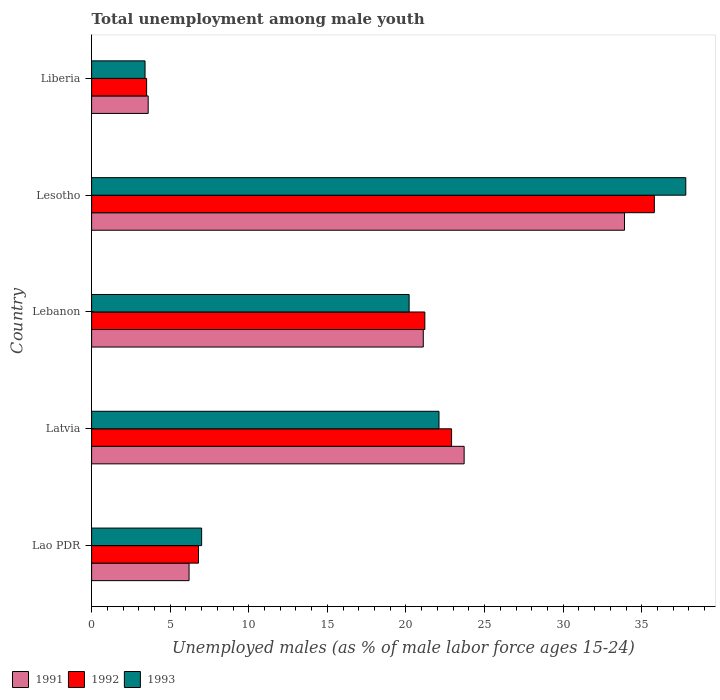How many different coloured bars are there?
Offer a terse response. 3. How many bars are there on the 1st tick from the top?
Your response must be concise. 3. How many bars are there on the 5th tick from the bottom?
Ensure brevity in your answer.  3. What is the label of the 5th group of bars from the top?
Your response must be concise. Lao PDR. In how many cases, is the number of bars for a given country not equal to the number of legend labels?
Offer a terse response. 0. What is the percentage of unemployed males in in 1993 in Lesotho?
Offer a very short reply. 37.8. Across all countries, what is the maximum percentage of unemployed males in in 1992?
Provide a succinct answer. 35.8. Across all countries, what is the minimum percentage of unemployed males in in 1993?
Ensure brevity in your answer.  3.4. In which country was the percentage of unemployed males in in 1991 maximum?
Your response must be concise. Lesotho. In which country was the percentage of unemployed males in in 1991 minimum?
Offer a terse response. Liberia. What is the total percentage of unemployed males in in 1993 in the graph?
Keep it short and to the point. 90.5. What is the difference between the percentage of unemployed males in in 1991 in Latvia and that in Lesotho?
Your answer should be compact. -10.2. What is the difference between the percentage of unemployed males in in 1993 in Lesotho and the percentage of unemployed males in in 1991 in Lebanon?
Offer a very short reply. 16.7. What is the average percentage of unemployed males in in 1993 per country?
Offer a very short reply. 18.1. What is the difference between the percentage of unemployed males in in 1993 and percentage of unemployed males in in 1992 in Lao PDR?
Provide a short and direct response. 0.2. What is the ratio of the percentage of unemployed males in in 1992 in Latvia to that in Liberia?
Give a very brief answer. 6.54. Is the difference between the percentage of unemployed males in in 1993 in Latvia and Lebanon greater than the difference between the percentage of unemployed males in in 1992 in Latvia and Lebanon?
Ensure brevity in your answer.  Yes. What is the difference between the highest and the second highest percentage of unemployed males in in 1993?
Your answer should be compact. 15.7. What is the difference between the highest and the lowest percentage of unemployed males in in 1991?
Offer a very short reply. 30.3. Is the sum of the percentage of unemployed males in in 1991 in Lao PDR and Liberia greater than the maximum percentage of unemployed males in in 1992 across all countries?
Provide a short and direct response. No. What does the 2nd bar from the bottom in Lao PDR represents?
Keep it short and to the point. 1992. Is it the case that in every country, the sum of the percentage of unemployed males in in 1991 and percentage of unemployed males in in 1993 is greater than the percentage of unemployed males in in 1992?
Your answer should be compact. Yes. Are the values on the major ticks of X-axis written in scientific E-notation?
Ensure brevity in your answer.  No. Where does the legend appear in the graph?
Ensure brevity in your answer.  Bottom left. How many legend labels are there?
Your answer should be very brief. 3. How are the legend labels stacked?
Offer a very short reply. Horizontal. What is the title of the graph?
Your answer should be compact. Total unemployment among male youth. What is the label or title of the X-axis?
Give a very brief answer. Unemployed males (as % of male labor force ages 15-24). What is the label or title of the Y-axis?
Your answer should be compact. Country. What is the Unemployed males (as % of male labor force ages 15-24) of 1991 in Lao PDR?
Offer a terse response. 6.2. What is the Unemployed males (as % of male labor force ages 15-24) of 1992 in Lao PDR?
Offer a very short reply. 6.8. What is the Unemployed males (as % of male labor force ages 15-24) of 1991 in Latvia?
Your answer should be very brief. 23.7. What is the Unemployed males (as % of male labor force ages 15-24) of 1992 in Latvia?
Offer a very short reply. 22.9. What is the Unemployed males (as % of male labor force ages 15-24) of 1993 in Latvia?
Your answer should be very brief. 22.1. What is the Unemployed males (as % of male labor force ages 15-24) in 1991 in Lebanon?
Offer a terse response. 21.1. What is the Unemployed males (as % of male labor force ages 15-24) in 1992 in Lebanon?
Offer a very short reply. 21.2. What is the Unemployed males (as % of male labor force ages 15-24) of 1993 in Lebanon?
Your answer should be compact. 20.2. What is the Unemployed males (as % of male labor force ages 15-24) in 1991 in Lesotho?
Make the answer very short. 33.9. What is the Unemployed males (as % of male labor force ages 15-24) in 1992 in Lesotho?
Give a very brief answer. 35.8. What is the Unemployed males (as % of male labor force ages 15-24) of 1993 in Lesotho?
Keep it short and to the point. 37.8. What is the Unemployed males (as % of male labor force ages 15-24) of 1991 in Liberia?
Offer a terse response. 3.6. What is the Unemployed males (as % of male labor force ages 15-24) in 1993 in Liberia?
Your answer should be compact. 3.4. Across all countries, what is the maximum Unemployed males (as % of male labor force ages 15-24) of 1991?
Ensure brevity in your answer.  33.9. Across all countries, what is the maximum Unemployed males (as % of male labor force ages 15-24) in 1992?
Offer a very short reply. 35.8. Across all countries, what is the maximum Unemployed males (as % of male labor force ages 15-24) of 1993?
Your answer should be very brief. 37.8. Across all countries, what is the minimum Unemployed males (as % of male labor force ages 15-24) of 1991?
Provide a succinct answer. 3.6. Across all countries, what is the minimum Unemployed males (as % of male labor force ages 15-24) of 1992?
Keep it short and to the point. 3.5. Across all countries, what is the minimum Unemployed males (as % of male labor force ages 15-24) in 1993?
Give a very brief answer. 3.4. What is the total Unemployed males (as % of male labor force ages 15-24) in 1991 in the graph?
Ensure brevity in your answer.  88.5. What is the total Unemployed males (as % of male labor force ages 15-24) in 1992 in the graph?
Offer a very short reply. 90.2. What is the total Unemployed males (as % of male labor force ages 15-24) in 1993 in the graph?
Offer a terse response. 90.5. What is the difference between the Unemployed males (as % of male labor force ages 15-24) of 1991 in Lao PDR and that in Latvia?
Provide a short and direct response. -17.5. What is the difference between the Unemployed males (as % of male labor force ages 15-24) in 1992 in Lao PDR and that in Latvia?
Ensure brevity in your answer.  -16.1. What is the difference between the Unemployed males (as % of male labor force ages 15-24) of 1993 in Lao PDR and that in Latvia?
Ensure brevity in your answer.  -15.1. What is the difference between the Unemployed males (as % of male labor force ages 15-24) in 1991 in Lao PDR and that in Lebanon?
Your answer should be very brief. -14.9. What is the difference between the Unemployed males (as % of male labor force ages 15-24) in 1992 in Lao PDR and that in Lebanon?
Your answer should be very brief. -14.4. What is the difference between the Unemployed males (as % of male labor force ages 15-24) in 1991 in Lao PDR and that in Lesotho?
Offer a terse response. -27.7. What is the difference between the Unemployed males (as % of male labor force ages 15-24) of 1992 in Lao PDR and that in Lesotho?
Your answer should be compact. -29. What is the difference between the Unemployed males (as % of male labor force ages 15-24) in 1993 in Lao PDR and that in Lesotho?
Ensure brevity in your answer.  -30.8. What is the difference between the Unemployed males (as % of male labor force ages 15-24) in 1991 in Lao PDR and that in Liberia?
Your response must be concise. 2.6. What is the difference between the Unemployed males (as % of male labor force ages 15-24) of 1992 in Lao PDR and that in Liberia?
Provide a succinct answer. 3.3. What is the difference between the Unemployed males (as % of male labor force ages 15-24) in 1992 in Latvia and that in Lebanon?
Provide a succinct answer. 1.7. What is the difference between the Unemployed males (as % of male labor force ages 15-24) in 1993 in Latvia and that in Lebanon?
Provide a short and direct response. 1.9. What is the difference between the Unemployed males (as % of male labor force ages 15-24) in 1991 in Latvia and that in Lesotho?
Your answer should be very brief. -10.2. What is the difference between the Unemployed males (as % of male labor force ages 15-24) of 1992 in Latvia and that in Lesotho?
Keep it short and to the point. -12.9. What is the difference between the Unemployed males (as % of male labor force ages 15-24) of 1993 in Latvia and that in Lesotho?
Make the answer very short. -15.7. What is the difference between the Unemployed males (as % of male labor force ages 15-24) in 1991 in Latvia and that in Liberia?
Provide a succinct answer. 20.1. What is the difference between the Unemployed males (as % of male labor force ages 15-24) of 1992 in Latvia and that in Liberia?
Offer a terse response. 19.4. What is the difference between the Unemployed males (as % of male labor force ages 15-24) in 1993 in Latvia and that in Liberia?
Provide a short and direct response. 18.7. What is the difference between the Unemployed males (as % of male labor force ages 15-24) in 1991 in Lebanon and that in Lesotho?
Keep it short and to the point. -12.8. What is the difference between the Unemployed males (as % of male labor force ages 15-24) of 1992 in Lebanon and that in Lesotho?
Make the answer very short. -14.6. What is the difference between the Unemployed males (as % of male labor force ages 15-24) in 1993 in Lebanon and that in Lesotho?
Ensure brevity in your answer.  -17.6. What is the difference between the Unemployed males (as % of male labor force ages 15-24) in 1991 in Lesotho and that in Liberia?
Your response must be concise. 30.3. What is the difference between the Unemployed males (as % of male labor force ages 15-24) of 1992 in Lesotho and that in Liberia?
Make the answer very short. 32.3. What is the difference between the Unemployed males (as % of male labor force ages 15-24) of 1993 in Lesotho and that in Liberia?
Give a very brief answer. 34.4. What is the difference between the Unemployed males (as % of male labor force ages 15-24) in 1991 in Lao PDR and the Unemployed males (as % of male labor force ages 15-24) in 1992 in Latvia?
Your answer should be compact. -16.7. What is the difference between the Unemployed males (as % of male labor force ages 15-24) in 1991 in Lao PDR and the Unemployed males (as % of male labor force ages 15-24) in 1993 in Latvia?
Your answer should be compact. -15.9. What is the difference between the Unemployed males (as % of male labor force ages 15-24) in 1992 in Lao PDR and the Unemployed males (as % of male labor force ages 15-24) in 1993 in Latvia?
Your response must be concise. -15.3. What is the difference between the Unemployed males (as % of male labor force ages 15-24) in 1991 in Lao PDR and the Unemployed males (as % of male labor force ages 15-24) in 1993 in Lebanon?
Give a very brief answer. -14. What is the difference between the Unemployed males (as % of male labor force ages 15-24) in 1991 in Lao PDR and the Unemployed males (as % of male labor force ages 15-24) in 1992 in Lesotho?
Offer a very short reply. -29.6. What is the difference between the Unemployed males (as % of male labor force ages 15-24) in 1991 in Lao PDR and the Unemployed males (as % of male labor force ages 15-24) in 1993 in Lesotho?
Provide a short and direct response. -31.6. What is the difference between the Unemployed males (as % of male labor force ages 15-24) of 1992 in Lao PDR and the Unemployed males (as % of male labor force ages 15-24) of 1993 in Lesotho?
Ensure brevity in your answer.  -31. What is the difference between the Unemployed males (as % of male labor force ages 15-24) in 1991 in Lao PDR and the Unemployed males (as % of male labor force ages 15-24) in 1992 in Liberia?
Your answer should be compact. 2.7. What is the difference between the Unemployed males (as % of male labor force ages 15-24) in 1992 in Lao PDR and the Unemployed males (as % of male labor force ages 15-24) in 1993 in Liberia?
Keep it short and to the point. 3.4. What is the difference between the Unemployed males (as % of male labor force ages 15-24) in 1991 in Latvia and the Unemployed males (as % of male labor force ages 15-24) in 1992 in Lebanon?
Make the answer very short. 2.5. What is the difference between the Unemployed males (as % of male labor force ages 15-24) of 1991 in Latvia and the Unemployed males (as % of male labor force ages 15-24) of 1993 in Lebanon?
Your response must be concise. 3.5. What is the difference between the Unemployed males (as % of male labor force ages 15-24) of 1992 in Latvia and the Unemployed males (as % of male labor force ages 15-24) of 1993 in Lebanon?
Your answer should be compact. 2.7. What is the difference between the Unemployed males (as % of male labor force ages 15-24) of 1991 in Latvia and the Unemployed males (as % of male labor force ages 15-24) of 1992 in Lesotho?
Your response must be concise. -12.1. What is the difference between the Unemployed males (as % of male labor force ages 15-24) in 1991 in Latvia and the Unemployed males (as % of male labor force ages 15-24) in 1993 in Lesotho?
Offer a very short reply. -14.1. What is the difference between the Unemployed males (as % of male labor force ages 15-24) in 1992 in Latvia and the Unemployed males (as % of male labor force ages 15-24) in 1993 in Lesotho?
Offer a terse response. -14.9. What is the difference between the Unemployed males (as % of male labor force ages 15-24) of 1991 in Latvia and the Unemployed males (as % of male labor force ages 15-24) of 1992 in Liberia?
Provide a succinct answer. 20.2. What is the difference between the Unemployed males (as % of male labor force ages 15-24) in 1991 in Latvia and the Unemployed males (as % of male labor force ages 15-24) in 1993 in Liberia?
Your answer should be very brief. 20.3. What is the difference between the Unemployed males (as % of male labor force ages 15-24) of 1992 in Latvia and the Unemployed males (as % of male labor force ages 15-24) of 1993 in Liberia?
Provide a succinct answer. 19.5. What is the difference between the Unemployed males (as % of male labor force ages 15-24) of 1991 in Lebanon and the Unemployed males (as % of male labor force ages 15-24) of 1992 in Lesotho?
Ensure brevity in your answer.  -14.7. What is the difference between the Unemployed males (as % of male labor force ages 15-24) of 1991 in Lebanon and the Unemployed males (as % of male labor force ages 15-24) of 1993 in Lesotho?
Provide a succinct answer. -16.7. What is the difference between the Unemployed males (as % of male labor force ages 15-24) in 1992 in Lebanon and the Unemployed males (as % of male labor force ages 15-24) in 1993 in Lesotho?
Make the answer very short. -16.6. What is the difference between the Unemployed males (as % of male labor force ages 15-24) of 1991 in Lesotho and the Unemployed males (as % of male labor force ages 15-24) of 1992 in Liberia?
Provide a short and direct response. 30.4. What is the difference between the Unemployed males (as % of male labor force ages 15-24) in 1991 in Lesotho and the Unemployed males (as % of male labor force ages 15-24) in 1993 in Liberia?
Offer a very short reply. 30.5. What is the difference between the Unemployed males (as % of male labor force ages 15-24) in 1992 in Lesotho and the Unemployed males (as % of male labor force ages 15-24) in 1993 in Liberia?
Your answer should be compact. 32.4. What is the average Unemployed males (as % of male labor force ages 15-24) of 1992 per country?
Give a very brief answer. 18.04. What is the difference between the Unemployed males (as % of male labor force ages 15-24) of 1992 and Unemployed males (as % of male labor force ages 15-24) of 1993 in Lao PDR?
Your answer should be very brief. -0.2. What is the difference between the Unemployed males (as % of male labor force ages 15-24) of 1991 and Unemployed males (as % of male labor force ages 15-24) of 1992 in Latvia?
Offer a terse response. 0.8. What is the difference between the Unemployed males (as % of male labor force ages 15-24) in 1991 and Unemployed males (as % of male labor force ages 15-24) in 1993 in Latvia?
Provide a short and direct response. 1.6. What is the difference between the Unemployed males (as % of male labor force ages 15-24) of 1992 and Unemployed males (as % of male labor force ages 15-24) of 1993 in Latvia?
Ensure brevity in your answer.  0.8. What is the difference between the Unemployed males (as % of male labor force ages 15-24) in 1991 and Unemployed males (as % of male labor force ages 15-24) in 1992 in Lebanon?
Your answer should be very brief. -0.1. What is the difference between the Unemployed males (as % of male labor force ages 15-24) of 1992 and Unemployed males (as % of male labor force ages 15-24) of 1993 in Lebanon?
Offer a terse response. 1. What is the ratio of the Unemployed males (as % of male labor force ages 15-24) in 1991 in Lao PDR to that in Latvia?
Offer a very short reply. 0.26. What is the ratio of the Unemployed males (as % of male labor force ages 15-24) in 1992 in Lao PDR to that in Latvia?
Your answer should be compact. 0.3. What is the ratio of the Unemployed males (as % of male labor force ages 15-24) in 1993 in Lao PDR to that in Latvia?
Your response must be concise. 0.32. What is the ratio of the Unemployed males (as % of male labor force ages 15-24) in 1991 in Lao PDR to that in Lebanon?
Ensure brevity in your answer.  0.29. What is the ratio of the Unemployed males (as % of male labor force ages 15-24) in 1992 in Lao PDR to that in Lebanon?
Make the answer very short. 0.32. What is the ratio of the Unemployed males (as % of male labor force ages 15-24) of 1993 in Lao PDR to that in Lebanon?
Provide a short and direct response. 0.35. What is the ratio of the Unemployed males (as % of male labor force ages 15-24) in 1991 in Lao PDR to that in Lesotho?
Ensure brevity in your answer.  0.18. What is the ratio of the Unemployed males (as % of male labor force ages 15-24) of 1992 in Lao PDR to that in Lesotho?
Give a very brief answer. 0.19. What is the ratio of the Unemployed males (as % of male labor force ages 15-24) in 1993 in Lao PDR to that in Lesotho?
Provide a succinct answer. 0.19. What is the ratio of the Unemployed males (as % of male labor force ages 15-24) of 1991 in Lao PDR to that in Liberia?
Make the answer very short. 1.72. What is the ratio of the Unemployed males (as % of male labor force ages 15-24) of 1992 in Lao PDR to that in Liberia?
Make the answer very short. 1.94. What is the ratio of the Unemployed males (as % of male labor force ages 15-24) in 1993 in Lao PDR to that in Liberia?
Offer a very short reply. 2.06. What is the ratio of the Unemployed males (as % of male labor force ages 15-24) in 1991 in Latvia to that in Lebanon?
Offer a very short reply. 1.12. What is the ratio of the Unemployed males (as % of male labor force ages 15-24) in 1992 in Latvia to that in Lebanon?
Make the answer very short. 1.08. What is the ratio of the Unemployed males (as % of male labor force ages 15-24) of 1993 in Latvia to that in Lebanon?
Provide a short and direct response. 1.09. What is the ratio of the Unemployed males (as % of male labor force ages 15-24) in 1991 in Latvia to that in Lesotho?
Your response must be concise. 0.7. What is the ratio of the Unemployed males (as % of male labor force ages 15-24) of 1992 in Latvia to that in Lesotho?
Make the answer very short. 0.64. What is the ratio of the Unemployed males (as % of male labor force ages 15-24) of 1993 in Latvia to that in Lesotho?
Your response must be concise. 0.58. What is the ratio of the Unemployed males (as % of male labor force ages 15-24) in 1991 in Latvia to that in Liberia?
Keep it short and to the point. 6.58. What is the ratio of the Unemployed males (as % of male labor force ages 15-24) of 1992 in Latvia to that in Liberia?
Offer a very short reply. 6.54. What is the ratio of the Unemployed males (as % of male labor force ages 15-24) in 1993 in Latvia to that in Liberia?
Make the answer very short. 6.5. What is the ratio of the Unemployed males (as % of male labor force ages 15-24) in 1991 in Lebanon to that in Lesotho?
Make the answer very short. 0.62. What is the ratio of the Unemployed males (as % of male labor force ages 15-24) in 1992 in Lebanon to that in Lesotho?
Ensure brevity in your answer.  0.59. What is the ratio of the Unemployed males (as % of male labor force ages 15-24) in 1993 in Lebanon to that in Lesotho?
Make the answer very short. 0.53. What is the ratio of the Unemployed males (as % of male labor force ages 15-24) of 1991 in Lebanon to that in Liberia?
Your response must be concise. 5.86. What is the ratio of the Unemployed males (as % of male labor force ages 15-24) of 1992 in Lebanon to that in Liberia?
Your answer should be compact. 6.06. What is the ratio of the Unemployed males (as % of male labor force ages 15-24) of 1993 in Lebanon to that in Liberia?
Provide a short and direct response. 5.94. What is the ratio of the Unemployed males (as % of male labor force ages 15-24) in 1991 in Lesotho to that in Liberia?
Your response must be concise. 9.42. What is the ratio of the Unemployed males (as % of male labor force ages 15-24) in 1992 in Lesotho to that in Liberia?
Keep it short and to the point. 10.23. What is the ratio of the Unemployed males (as % of male labor force ages 15-24) in 1993 in Lesotho to that in Liberia?
Your response must be concise. 11.12. What is the difference between the highest and the second highest Unemployed males (as % of male labor force ages 15-24) in 1991?
Your answer should be compact. 10.2. What is the difference between the highest and the second highest Unemployed males (as % of male labor force ages 15-24) in 1992?
Provide a succinct answer. 12.9. What is the difference between the highest and the lowest Unemployed males (as % of male labor force ages 15-24) of 1991?
Keep it short and to the point. 30.3. What is the difference between the highest and the lowest Unemployed males (as % of male labor force ages 15-24) in 1992?
Provide a short and direct response. 32.3. What is the difference between the highest and the lowest Unemployed males (as % of male labor force ages 15-24) in 1993?
Your answer should be very brief. 34.4. 